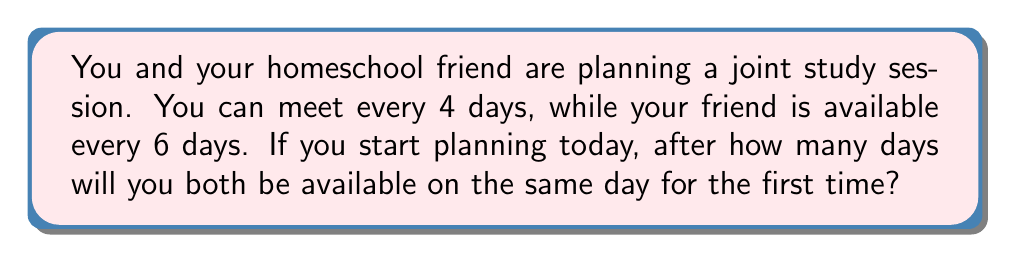Can you solve this math problem? To solve this problem, we need to find the least common multiple (LCM) of 4 and 6.

Step 1: List the multiples of each number.
Multiples of 4: 4, 8, 12, 16, 20, 24, ...
Multiples of 6: 6, 12, 18, 24, ...

Step 2: Identify the smallest number that appears in both lists.
The smallest common multiple is 12.

Alternatively, we can use the formula:
$$ LCM(a,b) = \frac{|a \times b|}{GCD(a,b)} $$

Where GCD is the Greatest Common Divisor.

Step 3: Find the GCD of 4 and 6 using the Euclidean algorithm.
$$ 6 = 1 \times 4 + 2 $$
$$ 4 = 2 \times 2 + 0 $$
So, $GCD(4,6) = 2$

Step 4: Apply the LCM formula.
$$ LCM(4,6) = \frac{|4 \times 6|}{2} = \frac{24}{2} = 12 $$

Therefore, you and your friend will both be available on the same day after 12 days.
Answer: 12 days 